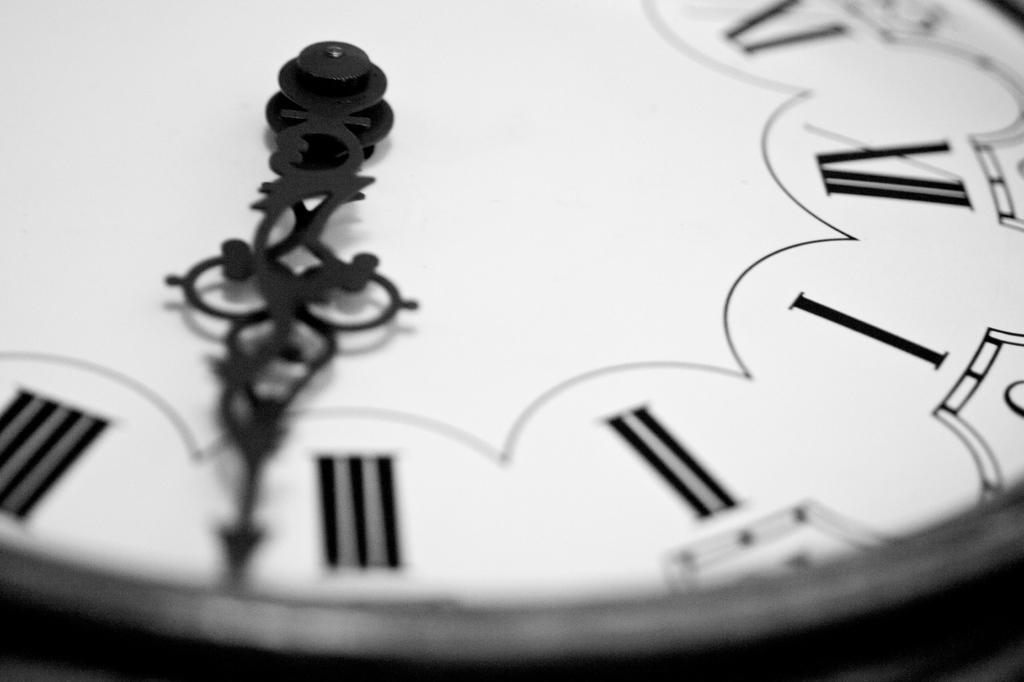<image>
Share a concise interpretation of the image provided. A clock currently has the ornate hand between the numerals III and IIII. 